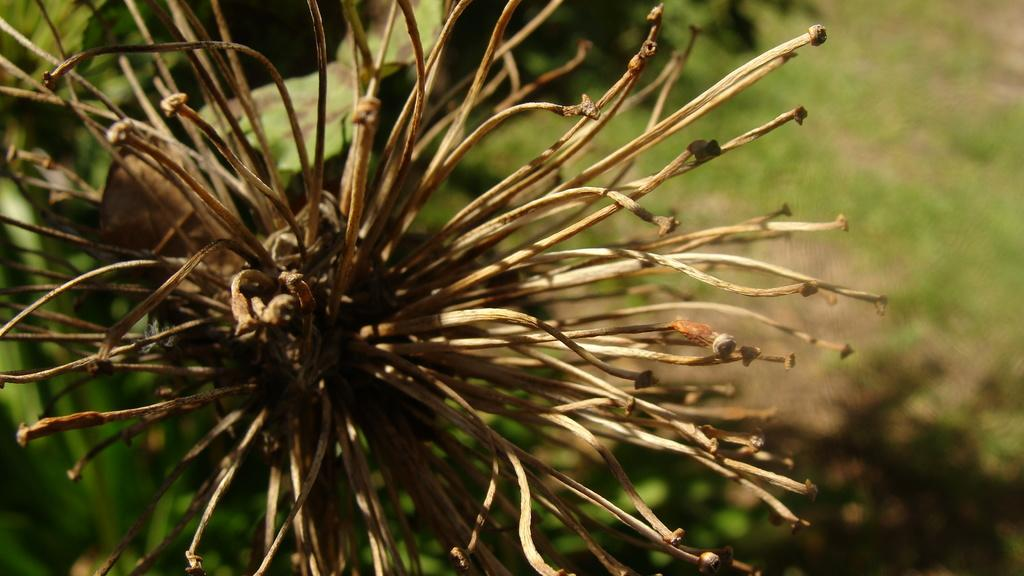What is the main subject of the image? There is a flower in the image. Can you describe the color of the flower? The flower has brown and cream colors. Is the flower part of a larger plant? Yes, the flower is attached to a plant. What is the color of the plant? The plant has a green color. What can be seen in the background of the image? There is ground and grass visible in the background of the image. What type of oil is being used to copy the flower in the image? There is no oil or copying process present in the image; it features a flower attached to a plant with a green color. 